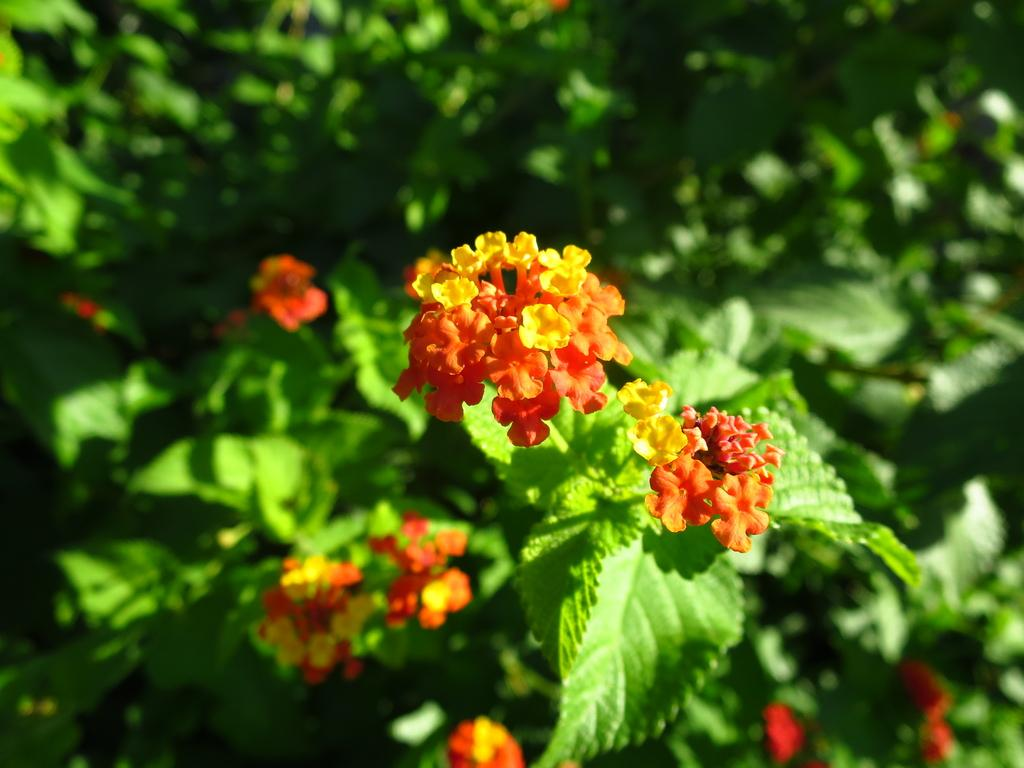What type of living organisms are in the image? The image contains plants. What specific feature can be observed on the plants? The plants have flowers. How many brothers are present in the image? There are no brothers present in the image, as it features plants with flowers. What type of committee can be seen in the image? There is no committee present in the image; it features plants with flowers. 